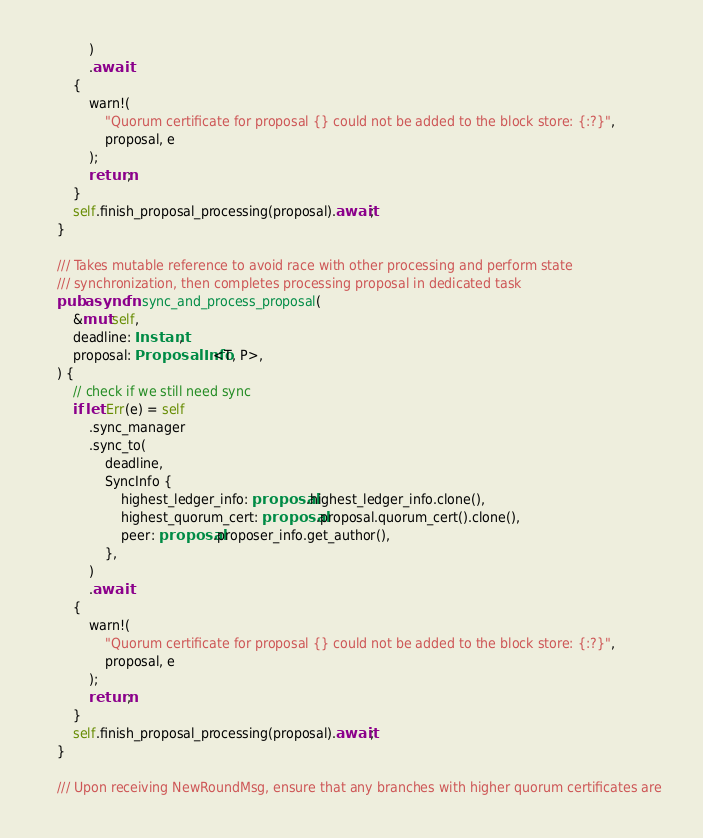Convert code to text. <code><loc_0><loc_0><loc_500><loc_500><_Rust_>            )
            .await
        {
            warn!(
                "Quorum certificate for proposal {} could not be added to the block store: {:?}",
                proposal, e
            );
            return;
        }
        self.finish_proposal_processing(proposal).await;
    }

    /// Takes mutable reference to avoid race with other processing and perform state
    /// synchronization, then completes processing proposal in dedicated task
    pub async fn sync_and_process_proposal(
        &mut self,
        deadline: Instant,
        proposal: ProposalInfo<T, P>,
    ) {
        // check if we still need sync
        if let Err(e) = self
            .sync_manager
            .sync_to(
                deadline,
                SyncInfo {
                    highest_ledger_info: proposal.highest_ledger_info.clone(),
                    highest_quorum_cert: proposal.proposal.quorum_cert().clone(),
                    peer: proposal.proposer_info.get_author(),
                },
            )
            .await
        {
            warn!(
                "Quorum certificate for proposal {} could not be added to the block store: {:?}",
                proposal, e
            );
            return;
        }
        self.finish_proposal_processing(proposal).await;
    }

    /// Upon receiving NewRoundMsg, ensure that any branches with higher quorum certificates are</code> 